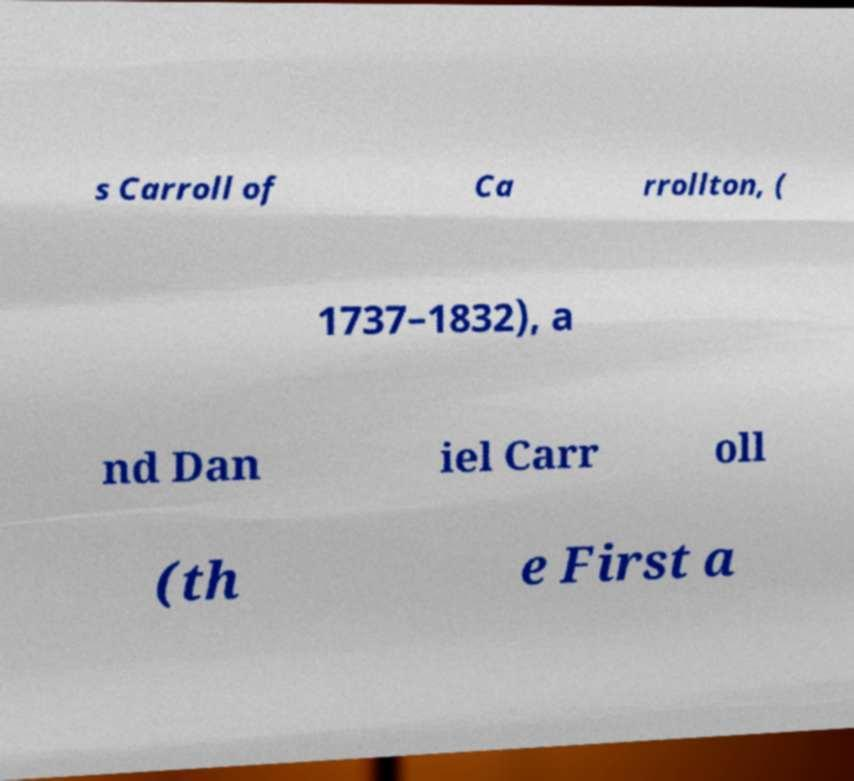Could you assist in decoding the text presented in this image and type it out clearly? s Carroll of Ca rrollton, ( 1737–1832), a nd Dan iel Carr oll (th e First a 